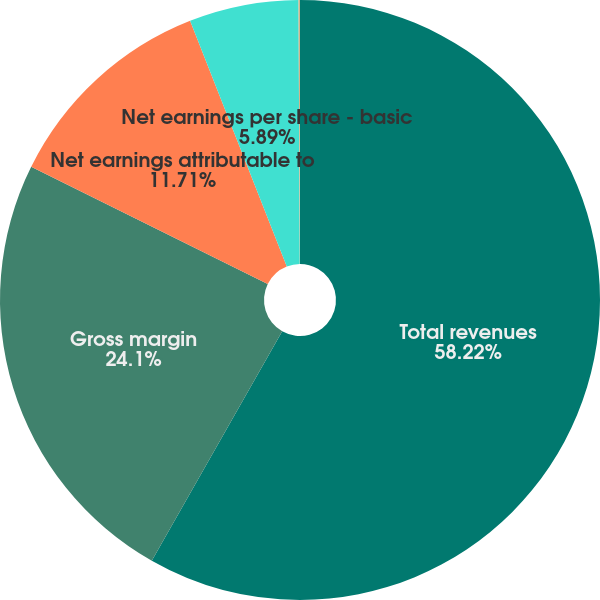Convert chart. <chart><loc_0><loc_0><loc_500><loc_500><pie_chart><fcel>Total revenues<fcel>Gross margin<fcel>Net earnings attributable to<fcel>Net earnings per share - basic<fcel>Net earnings per share -<nl><fcel>58.23%<fcel>24.1%<fcel>11.71%<fcel>5.89%<fcel>0.08%<nl></chart> 